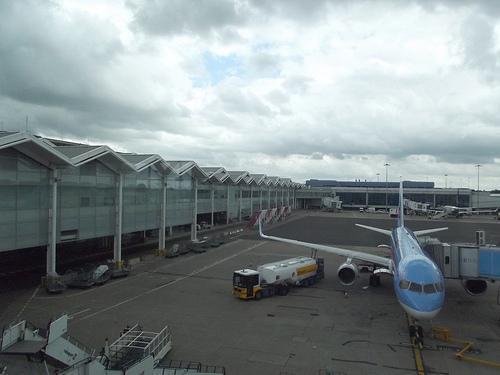How many trucks are by the plane?
Give a very brief answer. 1. How many planes are there?
Give a very brief answer. 1. 